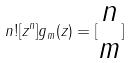Convert formula to latex. <formula><loc_0><loc_0><loc_500><loc_500>n ! [ z ^ { n } ] g _ { m } ( z ) = [ \begin{matrix} n \\ m \end{matrix} ]</formula> 